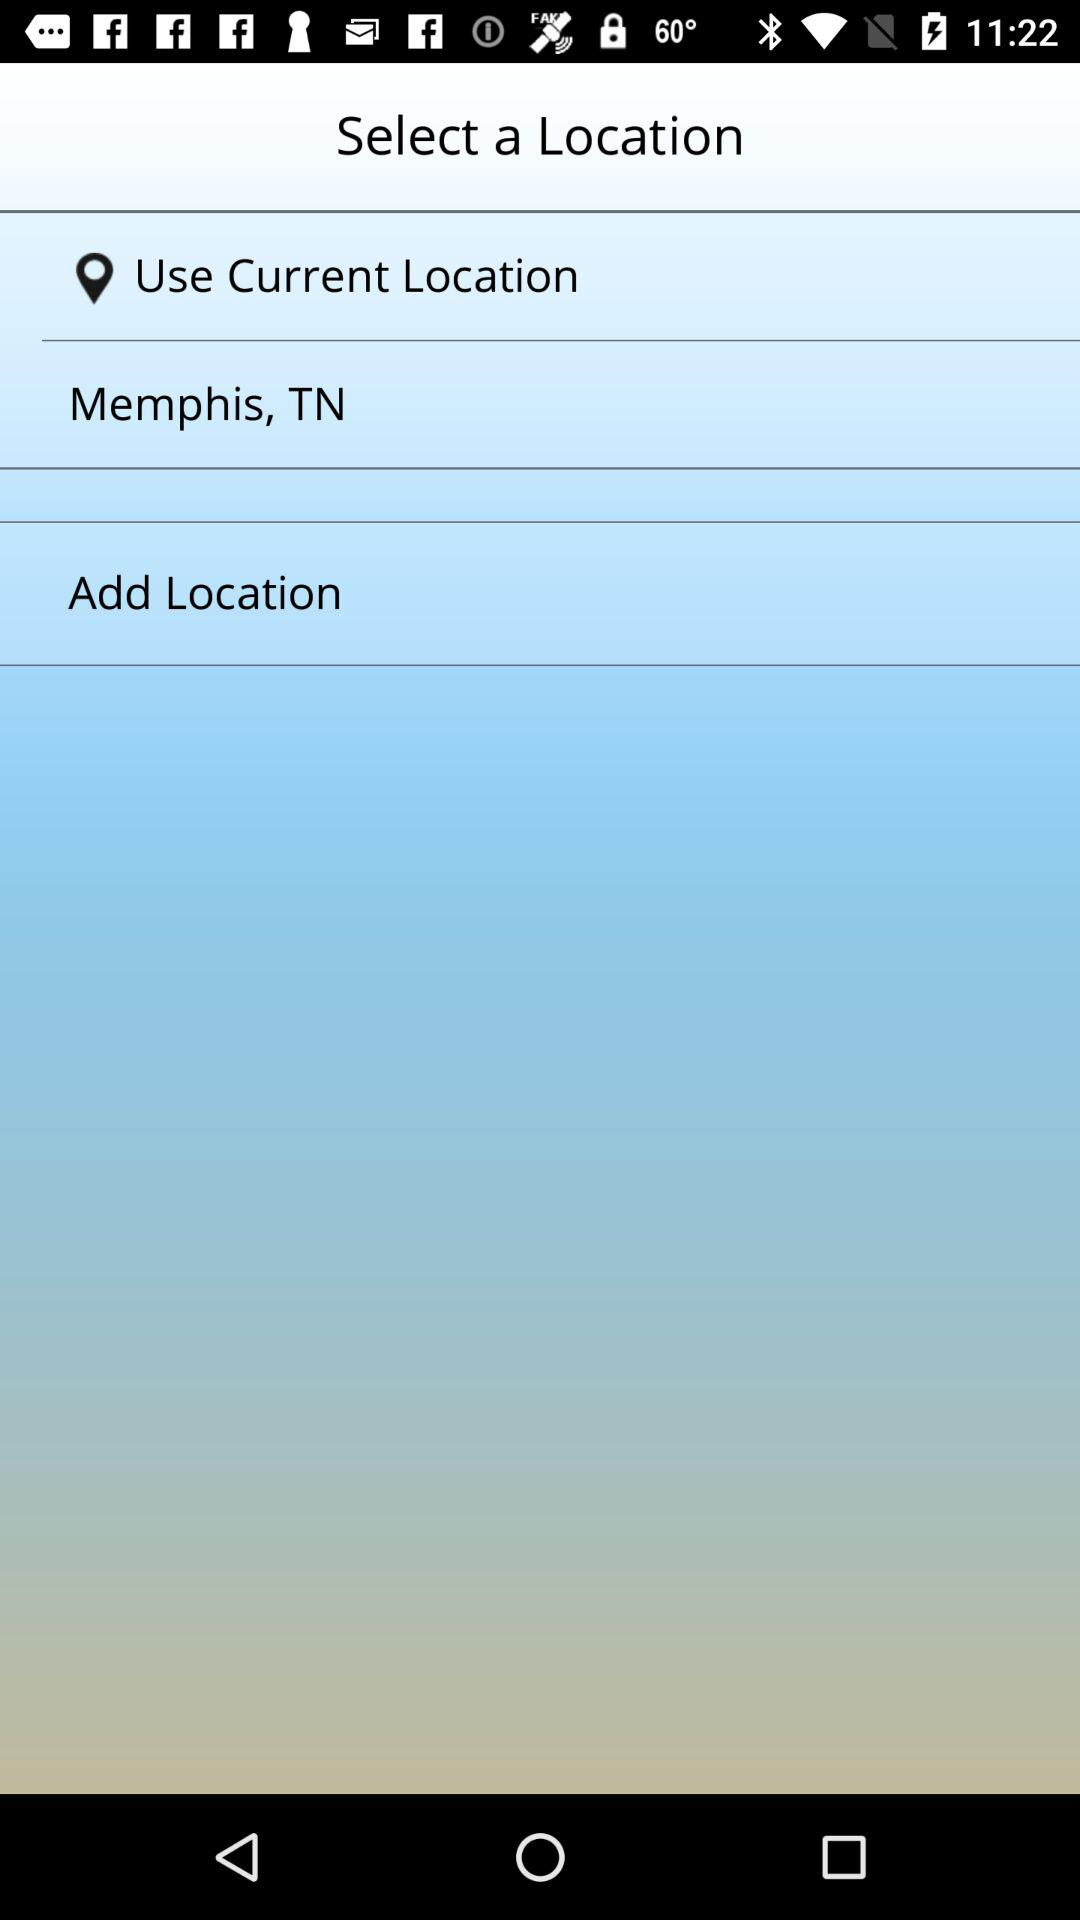What is the current location? The current location is Memphis, TN. 